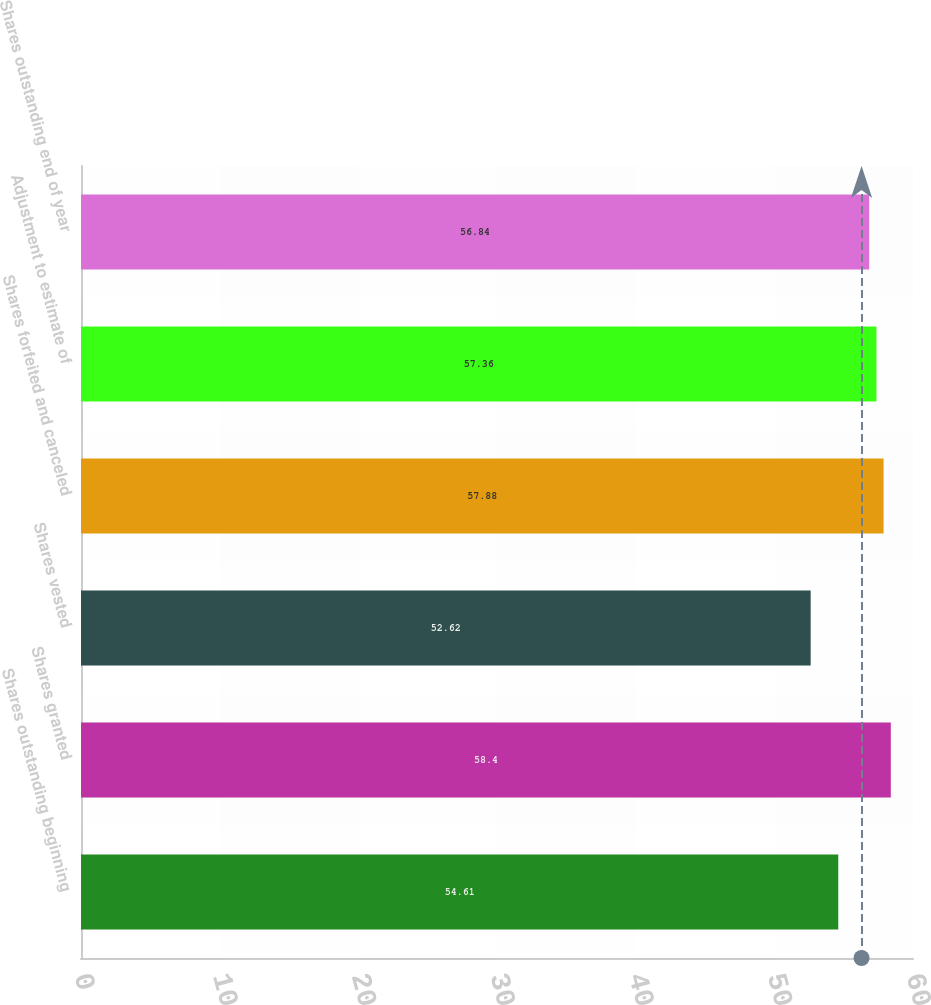<chart> <loc_0><loc_0><loc_500><loc_500><bar_chart><fcel>Shares outstanding beginning<fcel>Shares granted<fcel>Shares vested<fcel>Shares forfeited and canceled<fcel>Adjustment to estimate of<fcel>Shares outstanding end of year<nl><fcel>54.61<fcel>58.4<fcel>52.62<fcel>57.88<fcel>57.36<fcel>56.84<nl></chart> 